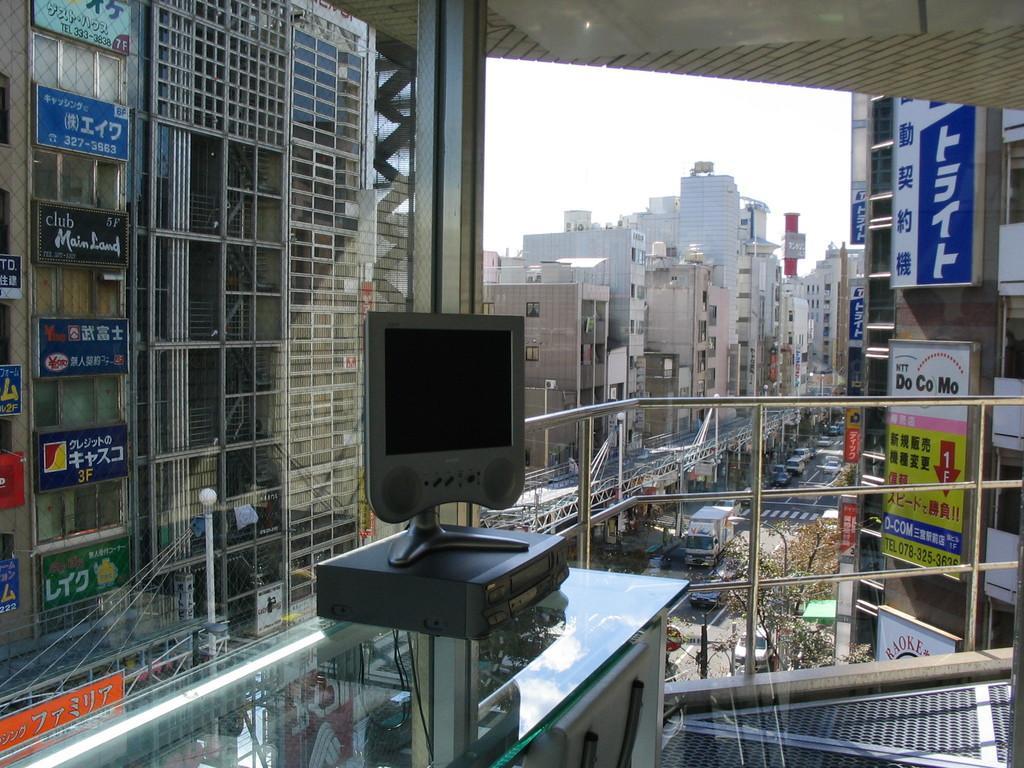Can you describe this image briefly? In this image, we can see a glass. Through the glass, we can see monitor, box, glass table, rods, walkway, buildings, poles, hoardings, banners, trees, road and vehicles. Background there is a sky. 